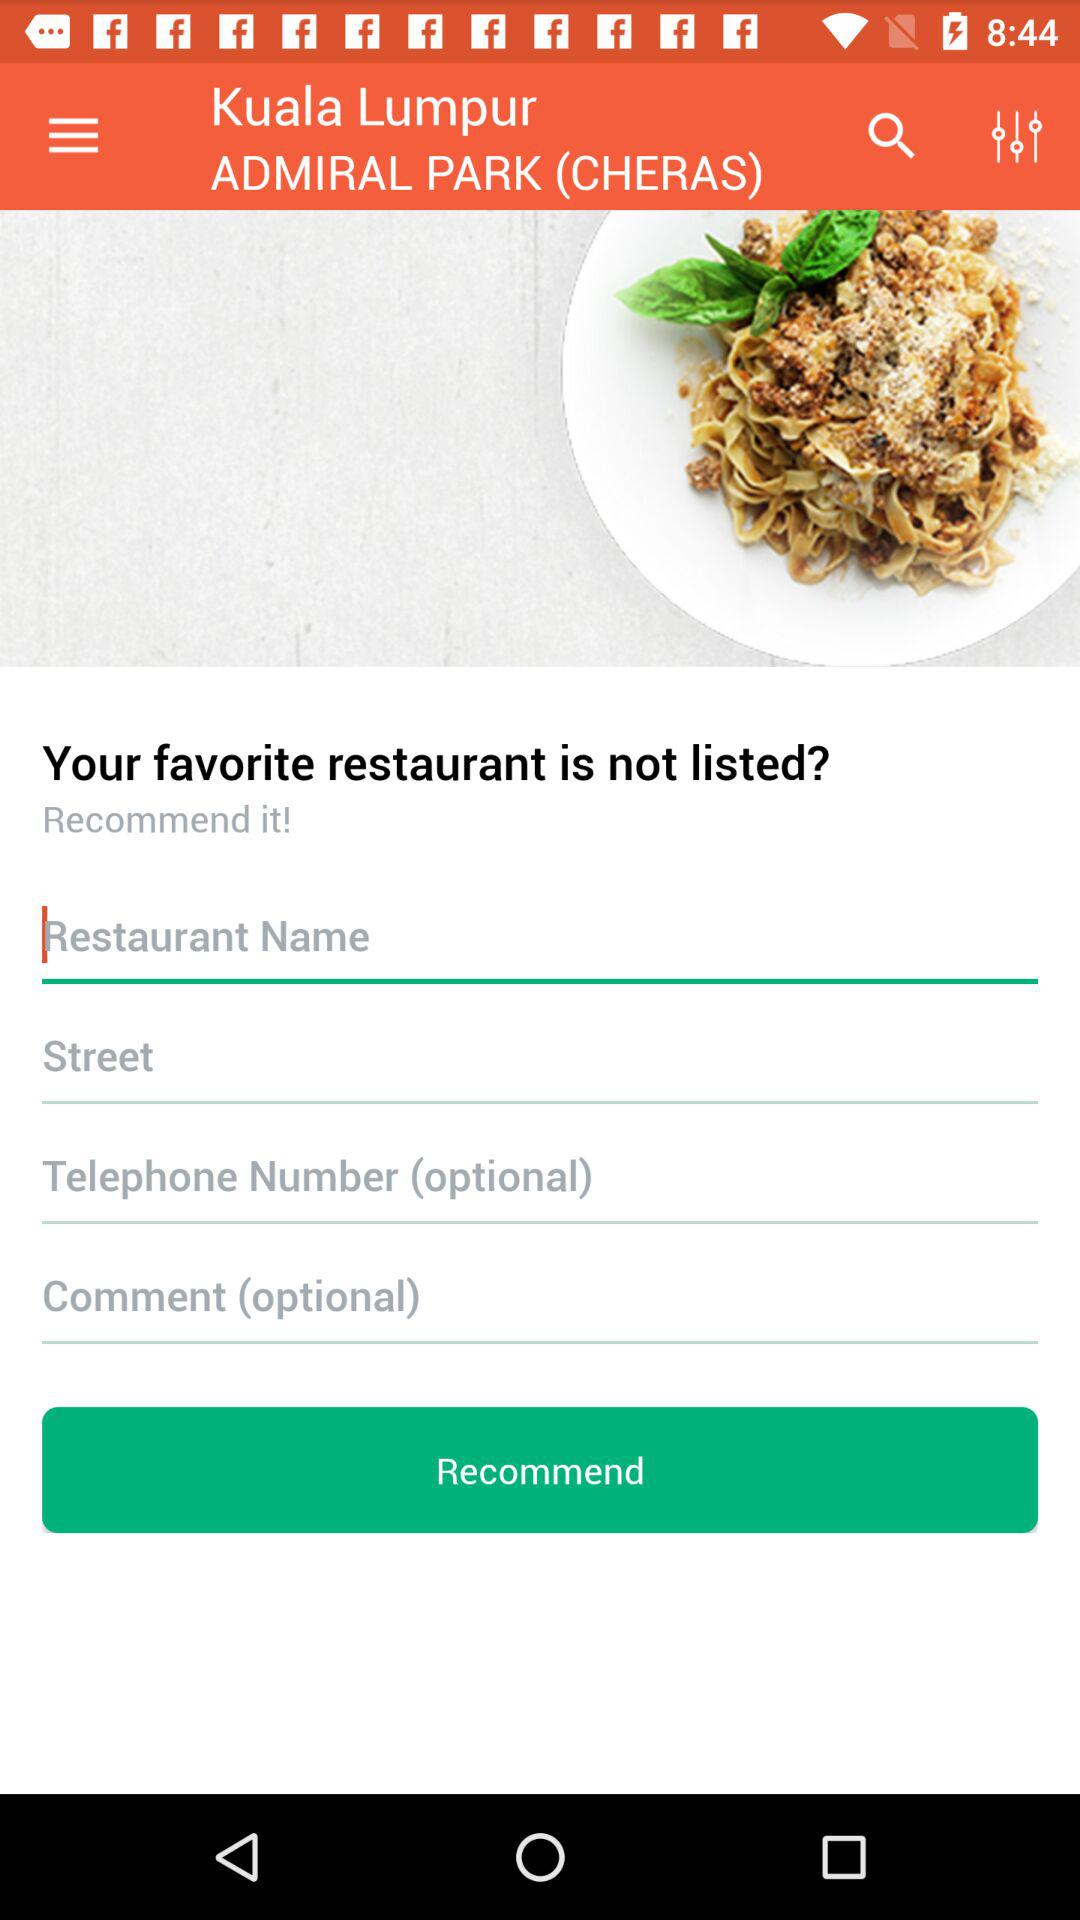What is the location? The location is Admiral Park (Cheras), Kuala Lumpur. 